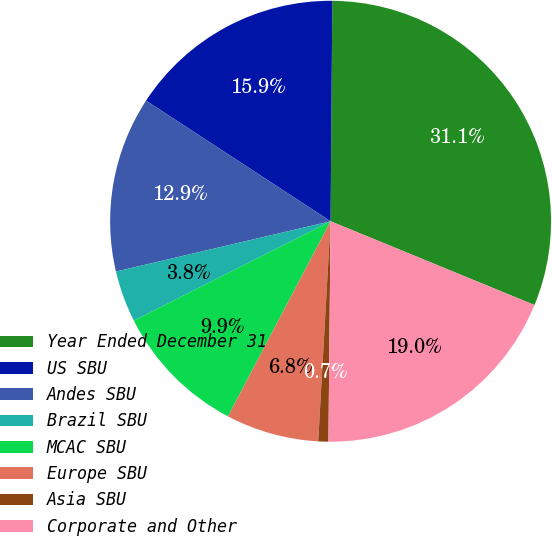<chart> <loc_0><loc_0><loc_500><loc_500><pie_chart><fcel>Year Ended December 31<fcel>US SBU<fcel>Andes SBU<fcel>Brazil SBU<fcel>MCAC SBU<fcel>Europe SBU<fcel>Asia SBU<fcel>Corporate and Other<nl><fcel>31.08%<fcel>15.91%<fcel>12.88%<fcel>3.78%<fcel>9.85%<fcel>6.81%<fcel>0.74%<fcel>18.95%<nl></chart> 